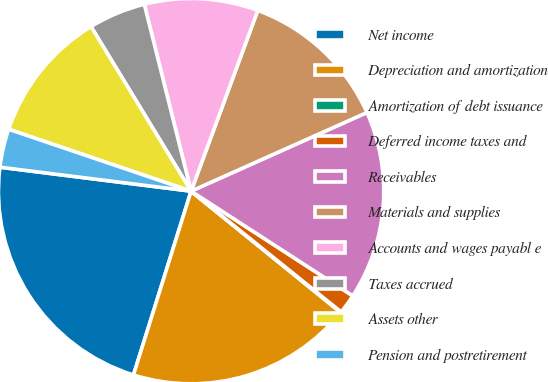<chart> <loc_0><loc_0><loc_500><loc_500><pie_chart><fcel>Net income<fcel>Depreciation and amortization<fcel>Amortization of debt issuance<fcel>Deferred income taxes and<fcel>Receivables<fcel>Materials and supplies<fcel>Accounts and wages payabl e<fcel>Taxes accrued<fcel>Assets other<fcel>Pension and postretirement<nl><fcel>22.15%<fcel>18.99%<fcel>0.06%<fcel>1.64%<fcel>15.84%<fcel>12.68%<fcel>9.53%<fcel>4.79%<fcel>11.1%<fcel>3.22%<nl></chart> 